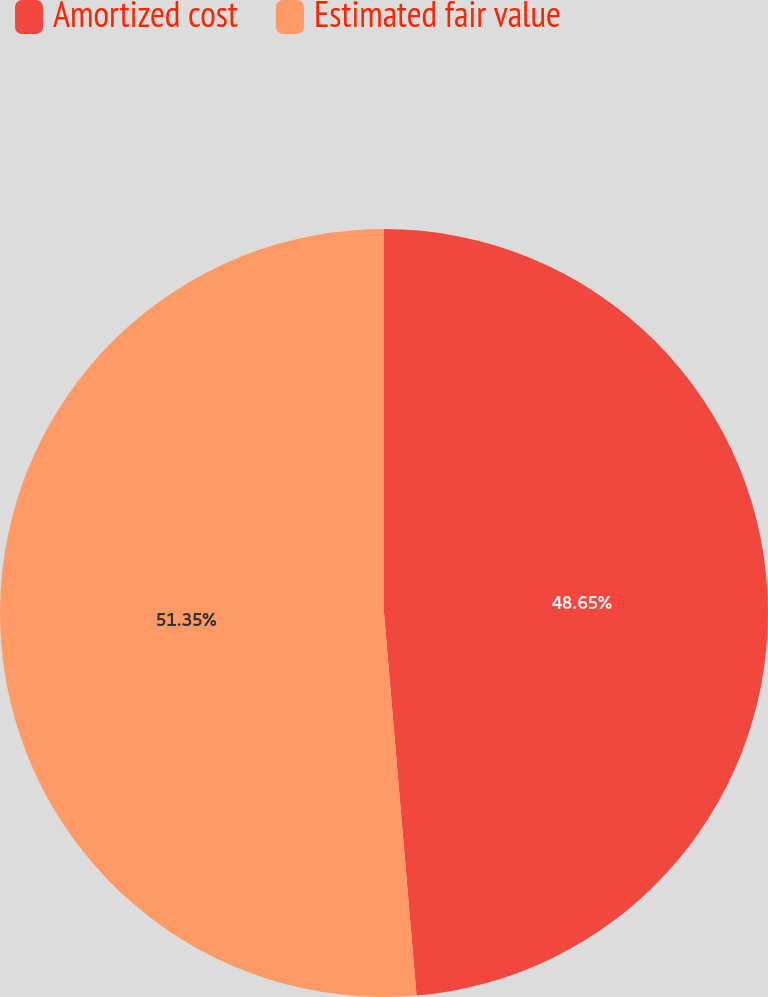Convert chart. <chart><loc_0><loc_0><loc_500><loc_500><pie_chart><fcel>Amortized cost<fcel>Estimated fair value<nl><fcel>48.65%<fcel>51.35%<nl></chart> 